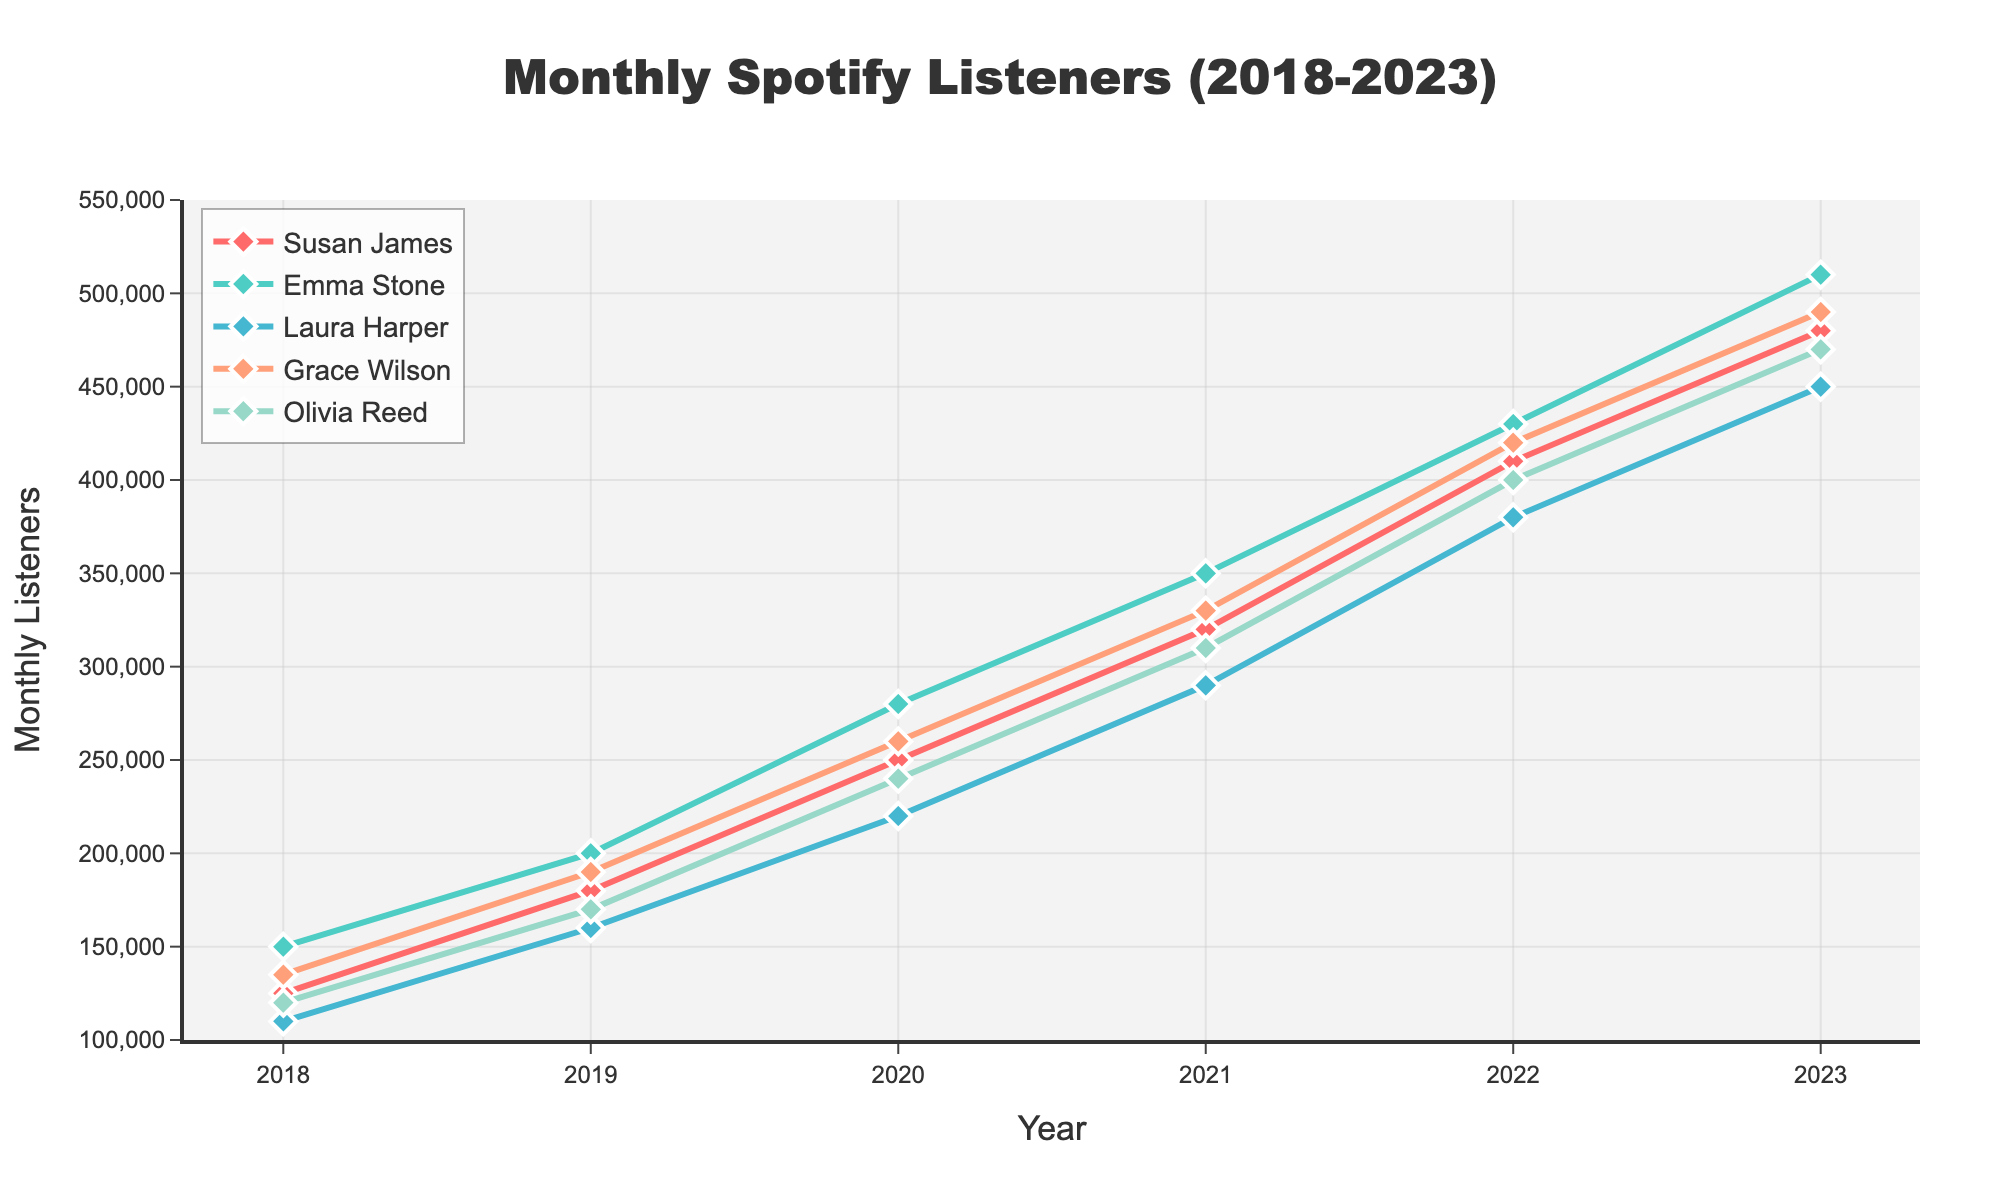Which artist had the highest number of monthly listeners in 2023? Look at the data points for 2023 and compare the values. Emma Stone has 510,000 monthly listeners, which is the highest among the listed artists.
Answer: Emma Stone By how much did Susan James' monthly listeners increase from 2018 to 2023? Calculate the difference between Susan James' monthly listeners in 2023 and 2018: 480,000 - 125,000 = 355,000.
Answer: 355,000 How did Laura Harper's monthly listeners change from 2019 to 2021? Check the values for Laura Harper in 2019 and 2021. In 2019, she had 160,000 listeners and in 2021, she had 290,000. The change is 290,000 - 160,000 = 130,000.
Answer: Increased by 130,000 Which artist showed the smallest increase in monthly listeners from 2022 to 2023? Calculate the difference for each artist between these years. Susan James (480,000-410,000=70,000), Emma Stone (510,000-430,000=80,000), Laura Harper (450,000-380,000=70,000), Grace Wilson (490,000-420,000=70,000), Olivia Reed (470,000-400,000=70,000). The differences show that Susan James, Laura Harper, Grace Wilson, and Olivia Reed had the smallest increase, all by 70,000.
Answer: Susan James, Laura Harper, Grace Wilson, and Olivia Reed On average, how many monthly listeners did Grace Wilson have each year over the last 5 years? Sum the values for each year for Grace Wilson and divide by the number of years: (135,000 + 190,000 + 260,000 + 330,000 + 420,000 + 490,000) / 6 = 1,825,000 / 6 ≈ 304,167.
Answer: 304,167 Which year did Susan James' monthly listeners reach 250,000? Look at the data for Susan James and find the year when her listeners were 250,000. This occurred in 2020.
Answer: 2020 Who had more monthly listeners in 2019, Susan James or Grace Wilson? Compare the 2019 values for Susan James and Grace Wilson. Susan James had 180,000 and Grace Wilson had 190,000.
Answer: Grace Wilson What was the average number of monthly listeners for Olivia Reed in 2021 and 2023? Calculate the average of the values for 2021 and 2023 for Olivia Reed: (310,000 + 470,000) / 2 = 780,000 / 2 = 390,000.
Answer: 390,000 Which two artists had the closest number of monthly listeners in 2018? Compare the 2018 values for all artists and find the two closest values. Susan James (125,000) and Olivia Reed (120,000) are the closest with a difference of 5,000.
Answer: Susan James and Olivia Reed 